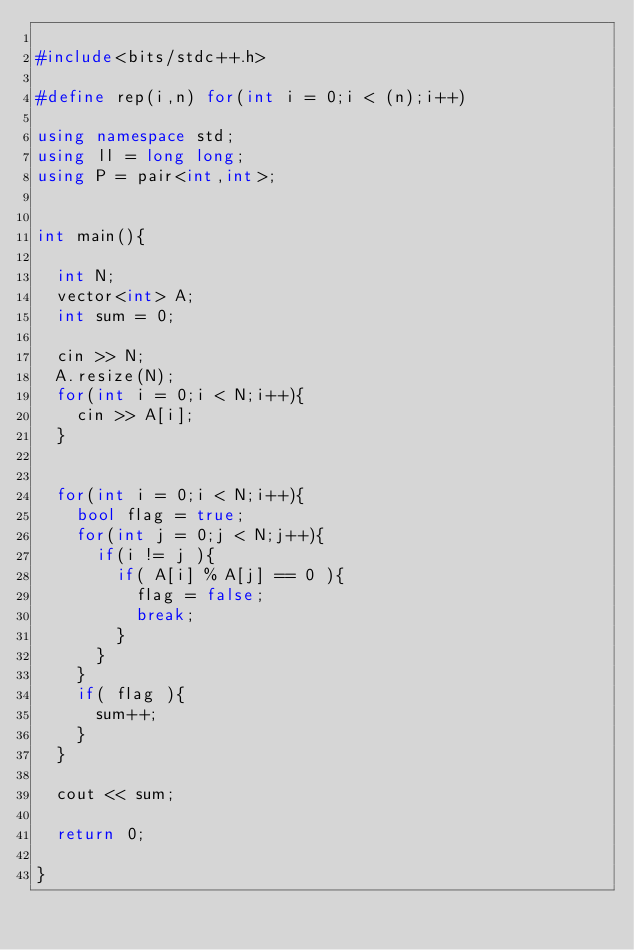<code> <loc_0><loc_0><loc_500><loc_500><_C++_>
#include<bits/stdc++.h>

#define rep(i,n) for(int i = 0;i < (n);i++)

using namespace std;
using ll = long long;
using P = pair<int,int>;


int main(){
	
	int N;
	vector<int> A;
	int sum = 0;
	
	cin >> N;
	A.resize(N);
	for(int i = 0;i < N;i++){
		cin >> A[i];
	}

	
	for(int i = 0;i < N;i++){
		bool flag = true;
		for(int j = 0;j < N;j++){
			if(i != j ){
				if( A[i] % A[j] == 0 ){
					flag = false;
					break;
				}
			}
		}
		if( flag ){
			sum++;
		}
	}
	
	cout << sum;

	return 0;
	
}</code> 